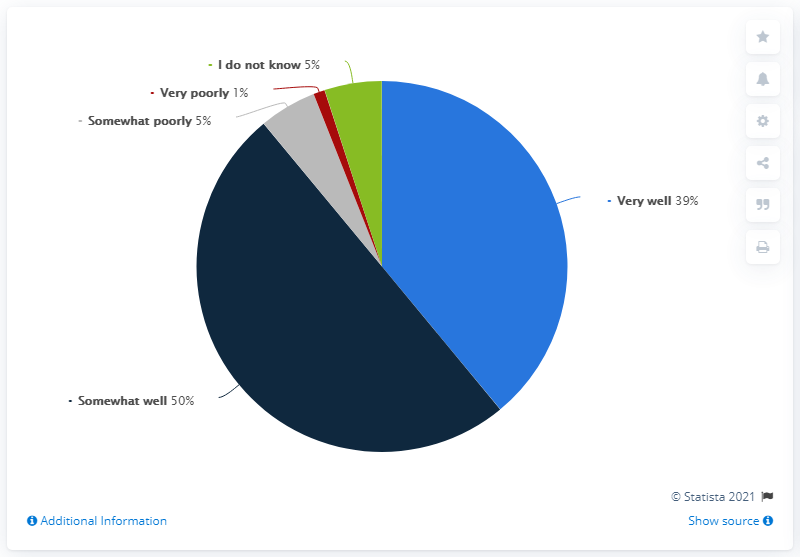Indicate a few pertinent items in this graphic. The largest pie is navy blue in color. The somewhat well opinion is significantly higher than all other opinions by a certain amount, ranging from 0 to... 